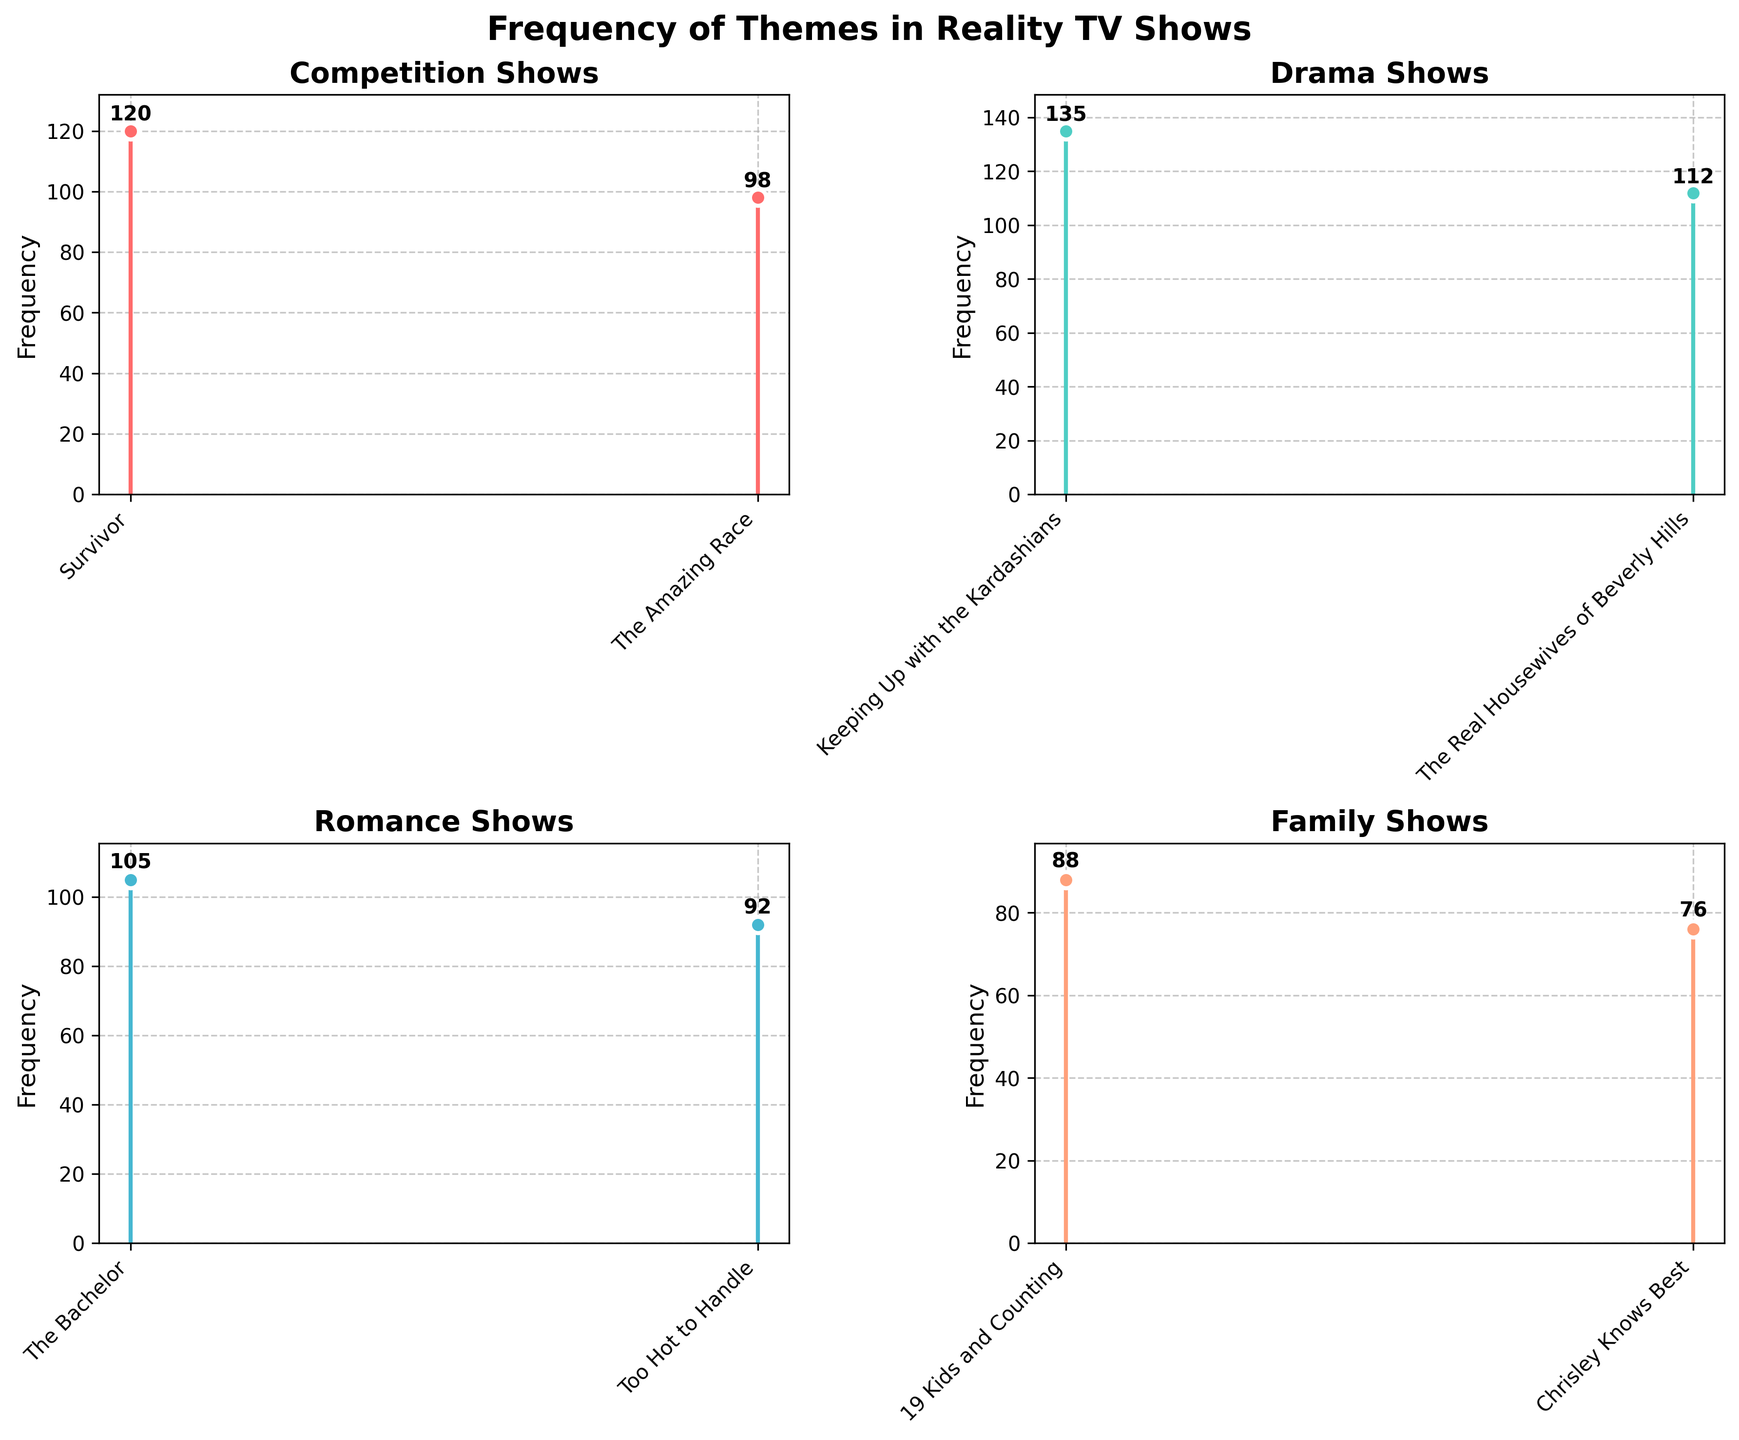Which theme has the highest frequency in any show? The subplots display frequencies of themes across different shows. By observing the data, "Drama" in "Keeping Up with the Kardashians" has the highest frequency of 135.
Answer: Drama What is the title of the figure? The main title of the figure is displayed at the top center of the plot. It reads "Frequency of Themes in Reality TV Shows".
Answer: Frequency of Themes in Reality TV Shows Which show has the lowest frequency and what is its theme? By examining the lowest data points across all subplots, "Chrisley Knows Best" under the "Family" theme has the lowest frequency of 76.
Answer: Chrisley Knows Best, Family How many themes are displayed in the figure? There are subplots for each unique theme. Observing the titles of the subplots, we can count four themes: Competition, Drama, Romance, and Family.
Answer: 4 What is the frequency difference between the highest and lowest frequency in the "Competition" theme? The highest frequency in the "Competition" subplot is for "Survivor" (120) and the lowest is for "The Amazing Race" (98). The difference is 120 - 98.
Answer: 22 Which "Romance" themed show has a higher frequency: "The Bachelor" or "Too Hot to Handle"? Looking at the stem values in the "Romance" subplot, "The Bachelor" has a frequency of 105 while "Too Hot to Handle" has 92. "The Bachelor" has a higher frequency.
Answer: The Bachelor What is the total combined frequency for the "Family" theme? Summing the values in the "Family" subplot: "19 Kids and Counting" (88) + "Chrisley Knows Best" (76). The total is 88 + 76.
Answer: 164 Compare the frequency of "Drama" themed shows. Which show has the least frequency under Drama? Observing the stem values in the "Drama" subplot, "Keeping Up with the Kardashians" has a frequency of 135 and "The Real Housewives of Beverly Hills" has 112. "The Real Housewives of Beverly Hills" has the least frequency.
Answer: The Real Housewives of Beverly Hills Which subplot has a taller y-axis range, "Romance" or "Family"? By observing the y-axis limits for both subplots, the "Romance" subplot ranges up to approx. 115 while "Family" goes up to 100. "Romance" has a taller y-axis range.
Answer: Romance 